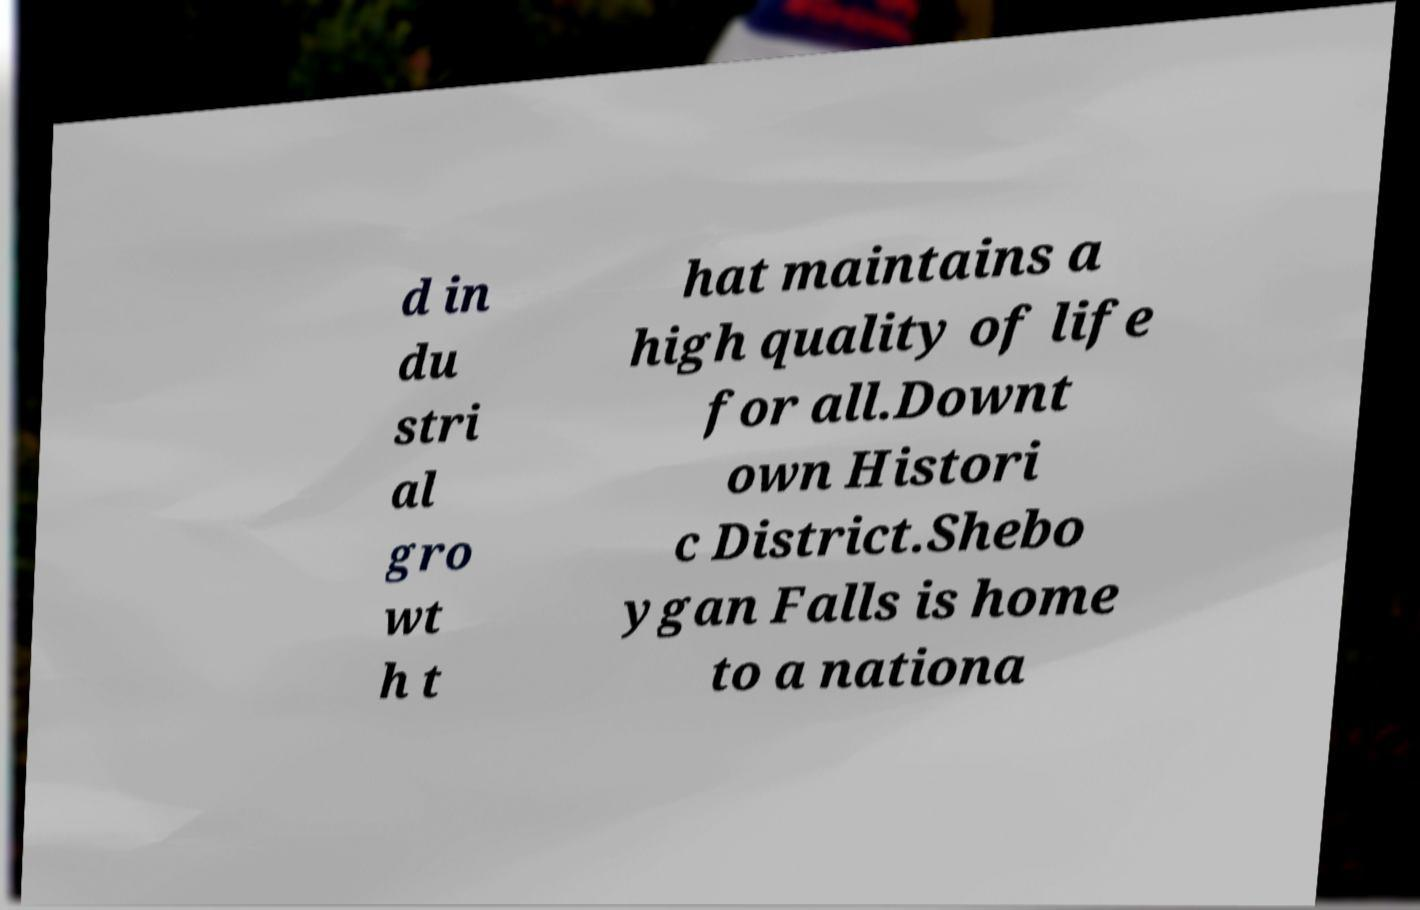Please read and relay the text visible in this image. What does it say? d in du stri al gro wt h t hat maintains a high quality of life for all.Downt own Histori c District.Shebo ygan Falls is home to a nationa 